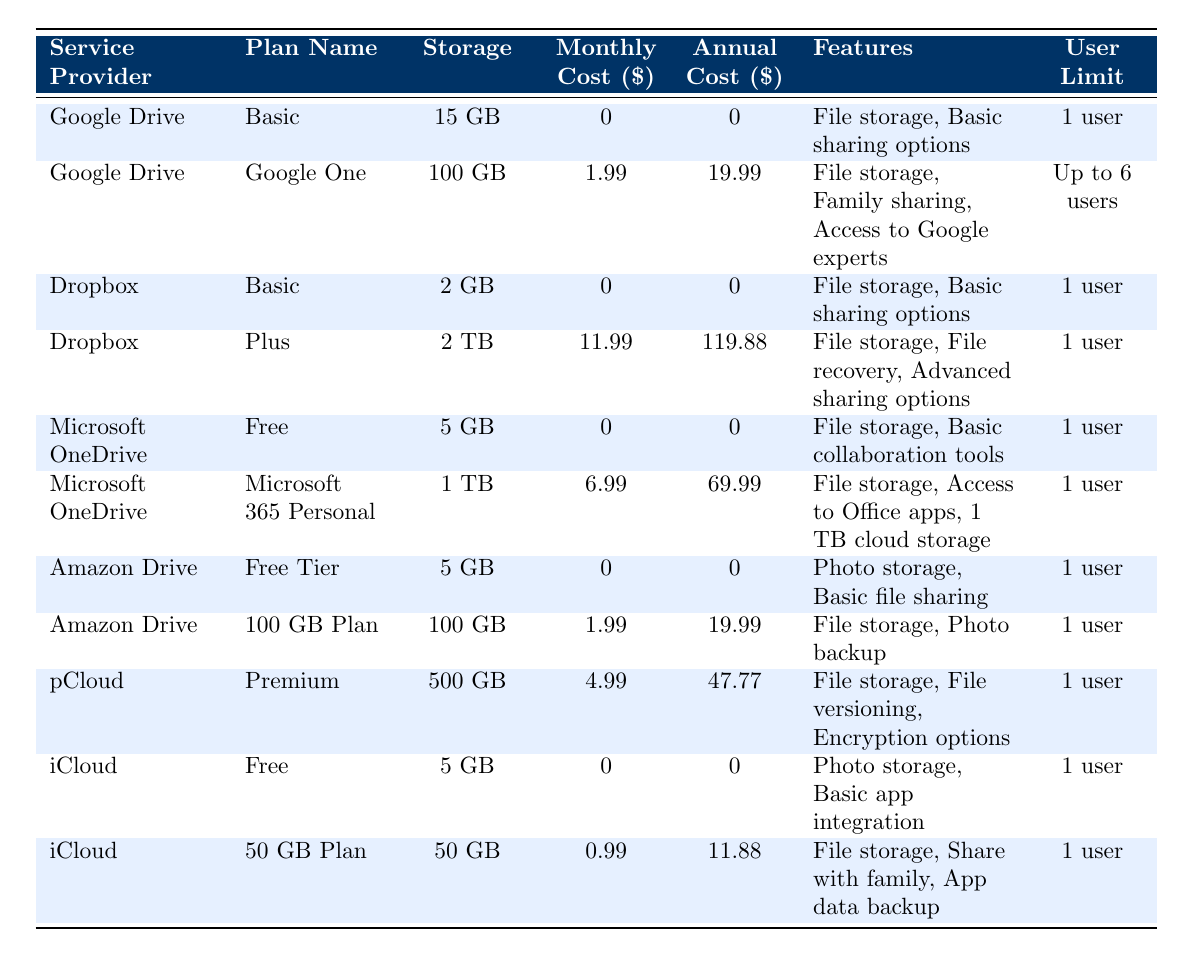What is the monthly cost of the Google One plan? According to the table, the monthly cost for the Google One plan under Google Drive is listed as 1.99.
Answer: 1.99 How much total storage is offered by the Microsoft OneDrive Personal plan? The Microsoft 365 Personal plan under Microsoft OneDrive offers a storage capacity of 1 TB as seen in the table.
Answer: 1 TB Is the Dropbox Basic plan free? The table shows that the monthly cost of the Dropbox Basic plan is 0, indicating that it is indeed free.
Answer: Yes Which plan offers the largest storage capacity? In examining the storage capacities across all plans, the Dropbox Plus plan offers the largest at 2 TB, as reflected in the table.
Answer: 2 TB What is the difference in annual cost between the pCloud Premium plan and the iCloud 50 GB Plan? The pCloud Premium plan costs 47.77 annually, while the iCloud 50 GB Plan costs 11.88. Therefore, the difference is 47.77 - 11.88 = 35.89.
Answer: 35.89 Are there any plans that allow family sharing? The Google One plan explicitly states that it allows family sharing (up to 5 members), thus confirming there is at least one such plan.
Answer: Yes What is the average monthly cost of all the plans listed? To calculate the average, first sum the monthly costs of all plans (0 + 1.99 + 0 + 11.99 + 0 + 6.99 + 0 + 1.99 + 4.99 + 0 + 0.99) = 27.94. There are 11 plans, so the average is 27.94 / 11 ≈ 2.54.
Answer: 2.54 Which service providers offer a free plan? Looking at the table, Google Drive, Dropbox, Microsoft OneDrive, Amazon Drive, and iCloud all have plans listed with a monthly cost of 0, indicating they all offer a free plan.
Answer: 5 providers What feature is unique to the Microsoft 365 Personal plan? The Microsoft 365 Personal plan includes access to Office apps, which is not mentioned in any other plans listed, making it a unique feature.
Answer: Access to Office apps 